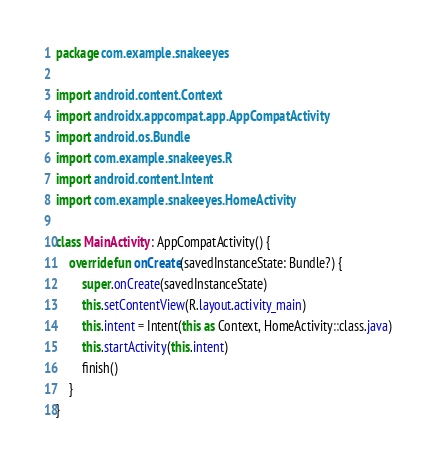<code> <loc_0><loc_0><loc_500><loc_500><_Kotlin_>package com.example.snakeeyes

import android.content.Context
import androidx.appcompat.app.AppCompatActivity
import android.os.Bundle
import com.example.snakeeyes.R
import android.content.Intent
import com.example.snakeeyes.HomeActivity

class MainActivity : AppCompatActivity() {
    override fun onCreate(savedInstanceState: Bundle?) {
        super.onCreate(savedInstanceState)
        this.setContentView(R.layout.activity_main)
        this.intent = Intent(this as Context, HomeActivity::class.java)
        this.startActivity(this.intent)
        finish()
    }
}</code> 